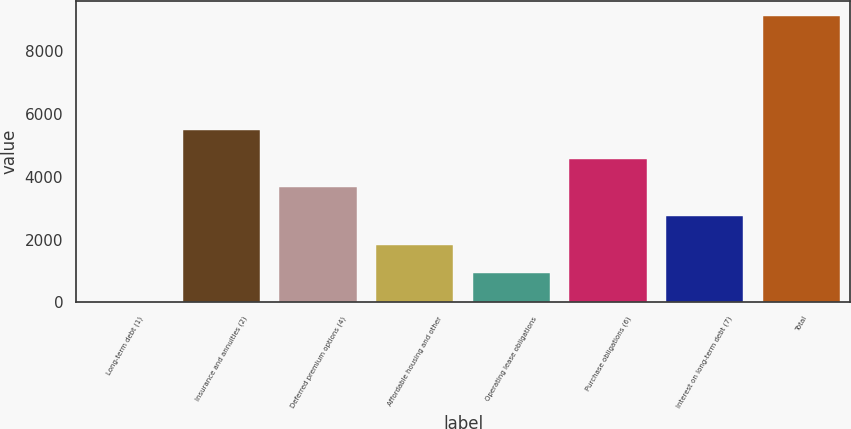Convert chart to OTSL. <chart><loc_0><loc_0><loc_500><loc_500><bar_chart><fcel>Long-term debt (1)<fcel>Insurance and annuities (2)<fcel>Deferred premium options (4)<fcel>Affordable housing and other<fcel>Operating lease obligations<fcel>Purchase obligations (6)<fcel>Interest on long-term debt (7)<fcel>Total<nl><fcel>12<fcel>5493<fcel>3666<fcel>1839<fcel>925.5<fcel>4579.5<fcel>2752.5<fcel>9147<nl></chart> 